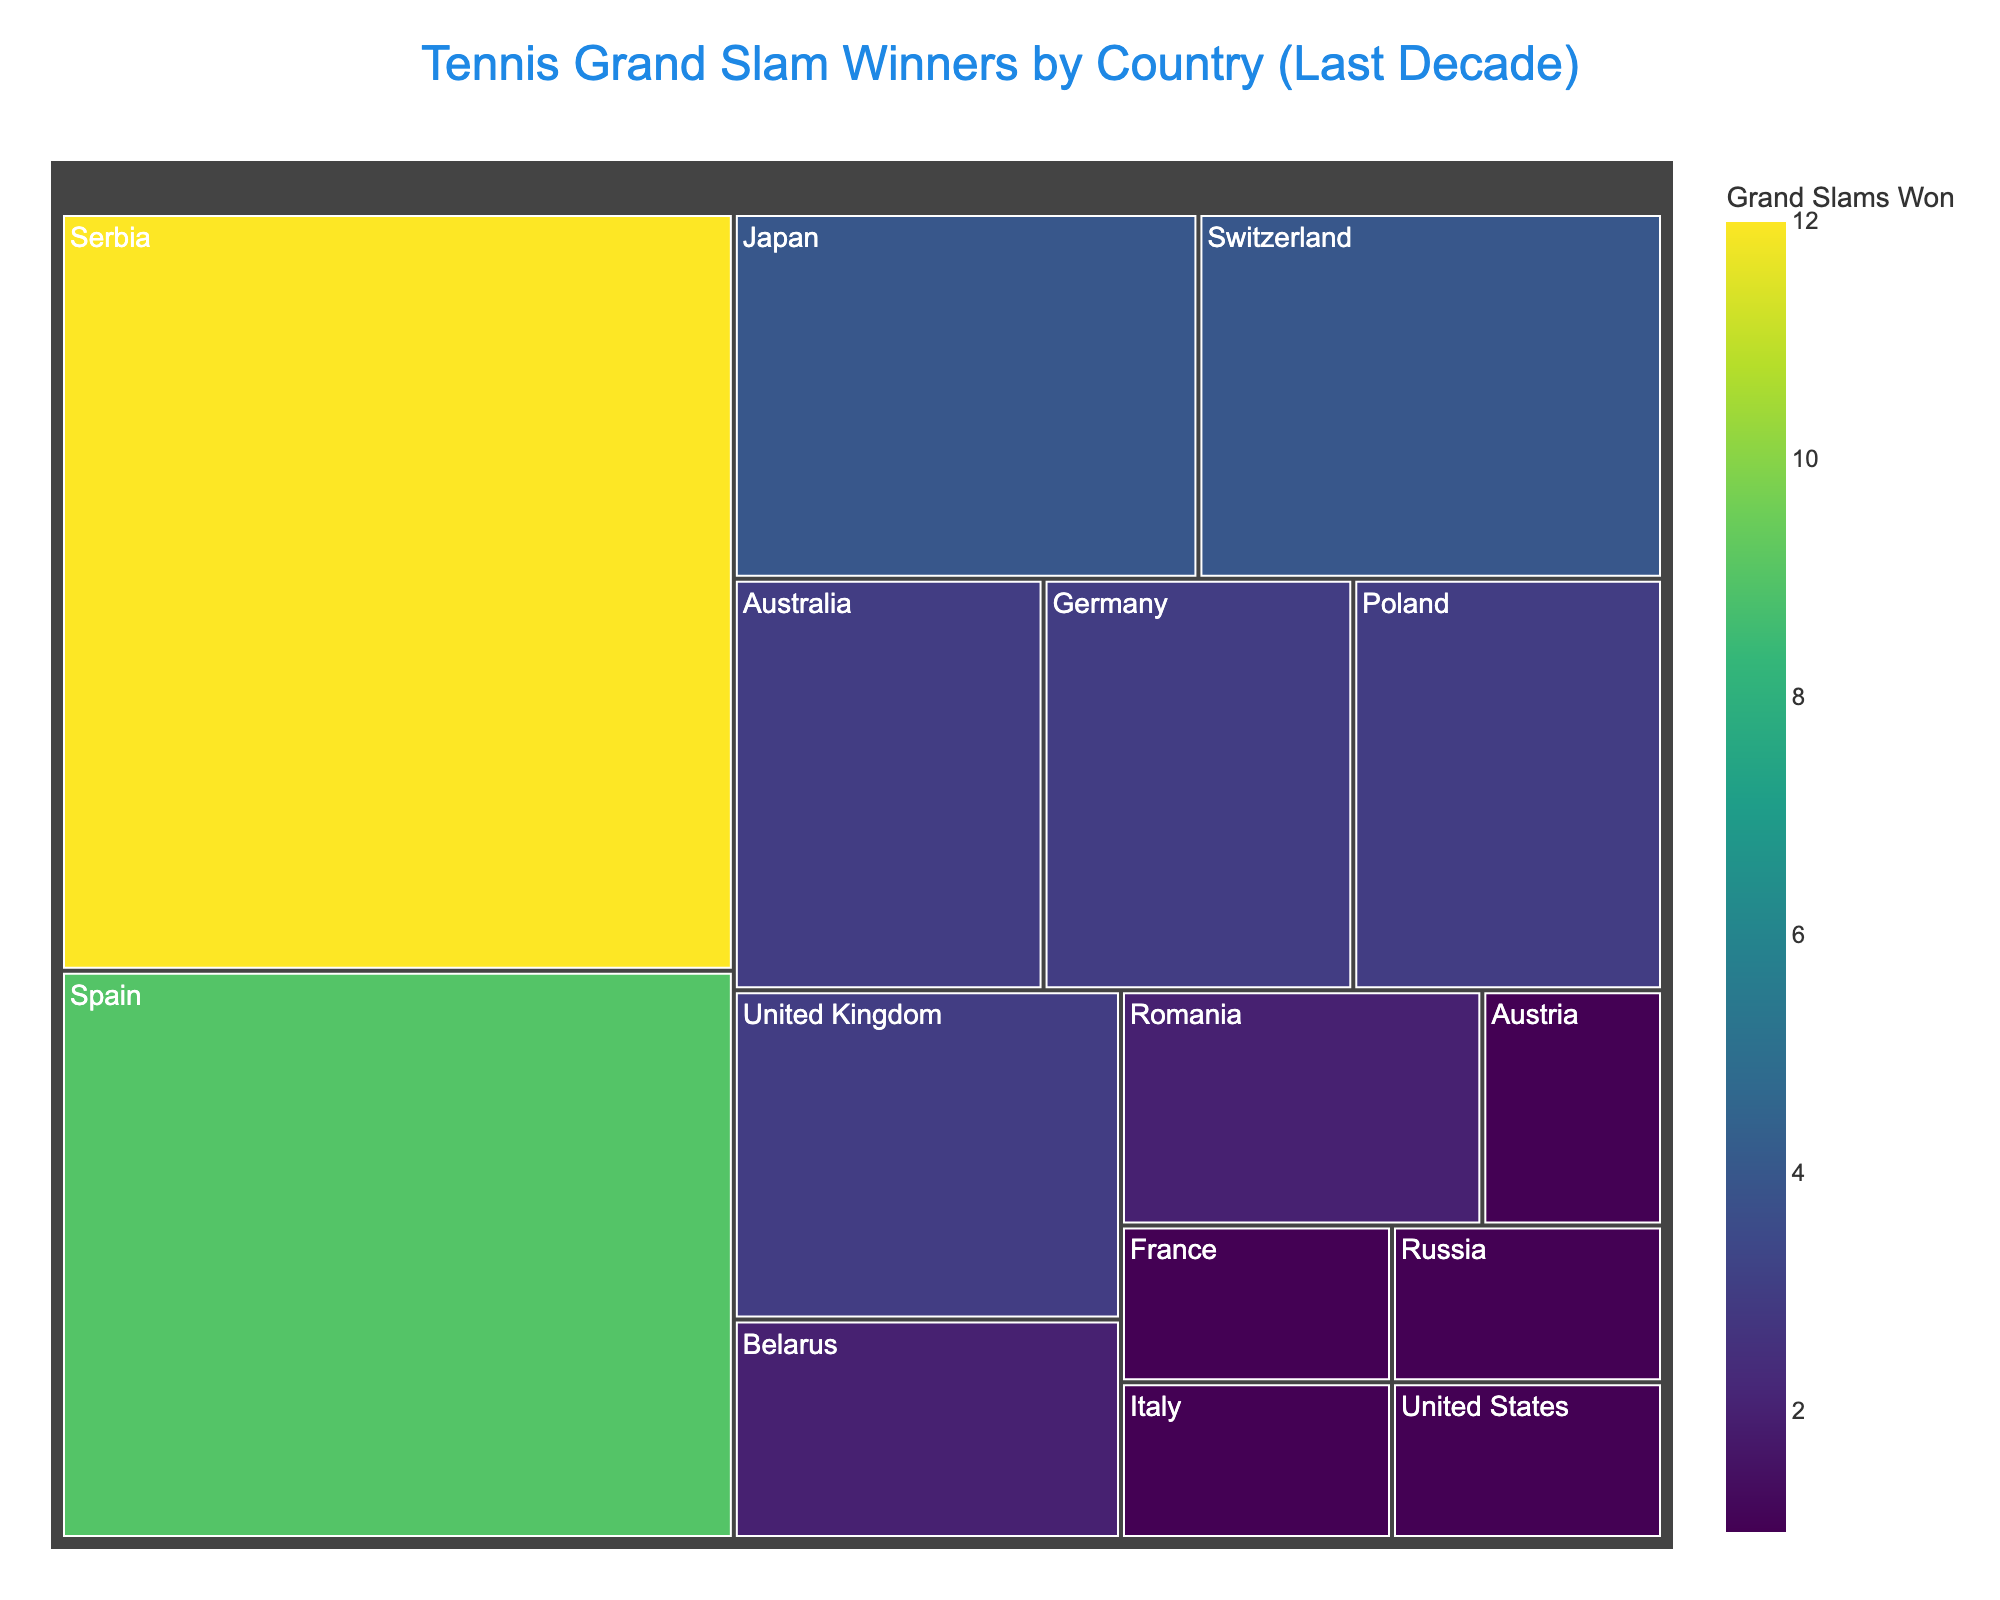How many Grand Slams has Novak Djokovic won in the past decade? Look at Serbia's segment in the treemap, it represents Novak Djokovic. The number of Grand Slams won by him is 12, as displayed within the box.
Answer: 12 Which country has the most Grand Slam titles in the past decade? Serbia's segment is the largest in the treemap and has the highest brightness, indicating the most Grand Slam wins, which is 12.
Answer: Serbia Compare Spain and Switzerland in terms of Grand Slam wins. Which country has more titles? Spain and Switzerland are represented by Rafael Nadal and Roger Federer, respectively. Spain's segment shows 9 Grand Slams, and Switzerland's segment shows 4. Spain has more titles.
Answer: Spain Calculate the total number of Grand Slam titles won by players from EU countries in the past decade. Summing up the Grand Slams for EU countries: United Kingdom (3), Spain (9), Romania (2), Poland (3), Germany (3), France (1), and Italy (1). Total = 3 + 9 + 2 + 3 + 3 + 1 + 1 = 22.
Answer: 22 What percentage of the total Grand Slam titles does Rafael Nadal contribute? Rafael Nadal won 9 Grand Slams. First, calculate the total Grand Slams won by all players: 12 (Djokovic) + 9 (Nadal) + 4 (Federer) + 3 (Murray) + 1 (Thiem) + 1 (Medvedev) + 1 (Kenin) + 4 (Osaka) + 3 (Barty) + 2 (Halep) + 3 (Świątek) + 3 (Kerber) + 2 (Azarenka) + 1 (Bartoli) + 1 (Pennetta) = 50. Nadal's percentage = (9/50) * 100 = 18%.
Answer: 18% Identify the players with exactly 3 Grand Slam wins. Look for segments with the value 3: Andy Murray (United Kingdom), Ashleigh Barty (Australia), Iga Świątek (Poland), and Angelique Kerber (Germany).
Answer: Andy Murray, Ashleigh Barty, Iga Świątek, Angelique Kerber Which player won more Grand Slams: Sofia Kenin or Daniil Medvedev? Check the segments for the United States (Sofia Kenin) and Russia (Daniil Medvedev). Both show 1 Grand Slam win within each of their segments.
Answer: Equal What is the smallest segment in the treemap, and which player does it represent? The segments with a value of 1 are the smallest, representing Dominic Thiem (Austria), Daniil Medvedev (Russia), Sofia Kenin (United States), Marion Bartoli (France), and Flavia Pennetta (Italy).
Answer: Dominic Thiem, Daniil Medvedev, Sofia Kenin, Marion Bartoli, Flavia Pennetta 